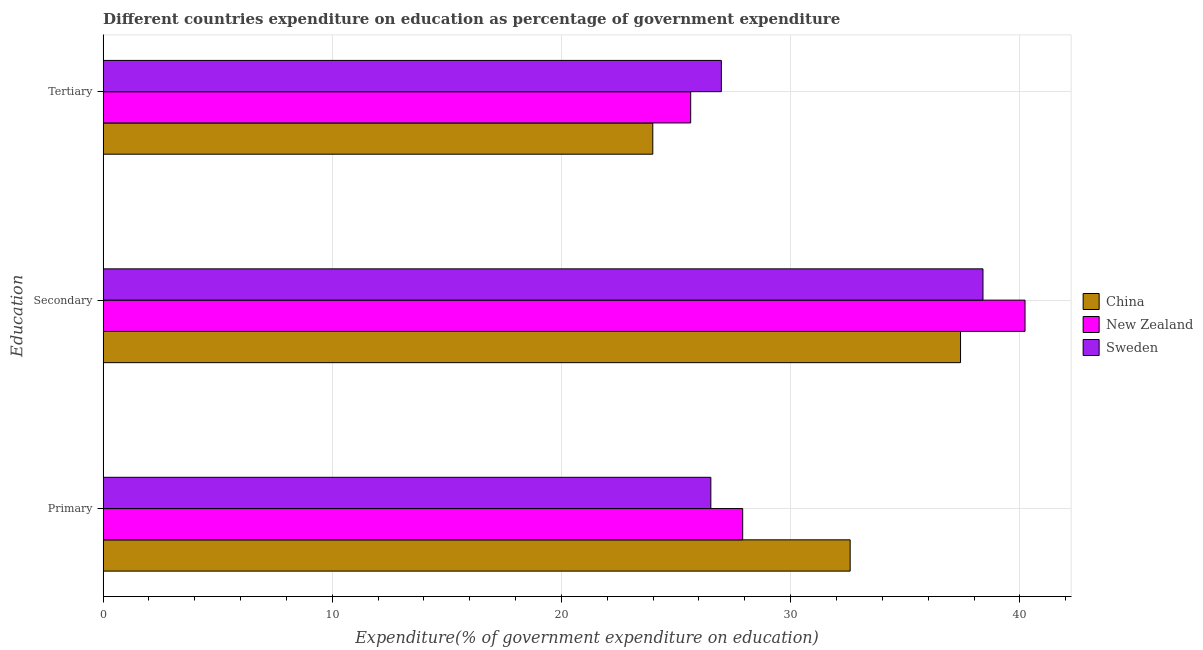How many different coloured bars are there?
Keep it short and to the point. 3. Are the number of bars on each tick of the Y-axis equal?
Provide a succinct answer. Yes. What is the label of the 2nd group of bars from the top?
Offer a very short reply. Secondary. What is the expenditure on tertiary education in China?
Keep it short and to the point. 23.98. Across all countries, what is the maximum expenditure on primary education?
Ensure brevity in your answer.  32.6. Across all countries, what is the minimum expenditure on tertiary education?
Your answer should be compact. 23.98. What is the total expenditure on primary education in the graph?
Give a very brief answer. 87.02. What is the difference between the expenditure on tertiary education in China and that in New Zealand?
Your answer should be compact. -1.65. What is the difference between the expenditure on primary education in New Zealand and the expenditure on tertiary education in Sweden?
Your answer should be compact. 0.93. What is the average expenditure on secondary education per country?
Offer a terse response. 38.68. What is the difference between the expenditure on secondary education and expenditure on tertiary education in Sweden?
Keep it short and to the point. 11.42. In how many countries, is the expenditure on secondary education greater than 6 %?
Offer a terse response. 3. What is the ratio of the expenditure on tertiary education in China to that in New Zealand?
Your response must be concise. 0.94. Is the expenditure on tertiary education in China less than that in New Zealand?
Give a very brief answer. Yes. What is the difference between the highest and the second highest expenditure on secondary education?
Your answer should be compact. 1.84. What is the difference between the highest and the lowest expenditure on secondary education?
Ensure brevity in your answer.  2.81. In how many countries, is the expenditure on tertiary education greater than the average expenditure on tertiary education taken over all countries?
Your response must be concise. 2. Is the sum of the expenditure on primary education in New Zealand and Sweden greater than the maximum expenditure on secondary education across all countries?
Your answer should be compact. Yes. What does the 3rd bar from the top in Secondary represents?
Offer a terse response. China. What does the 2nd bar from the bottom in Secondary represents?
Provide a short and direct response. New Zealand. Is it the case that in every country, the sum of the expenditure on primary education and expenditure on secondary education is greater than the expenditure on tertiary education?
Your answer should be compact. Yes. How many bars are there?
Your answer should be compact. 9. What is the difference between two consecutive major ticks on the X-axis?
Make the answer very short. 10. Are the values on the major ticks of X-axis written in scientific E-notation?
Provide a succinct answer. No. Does the graph contain any zero values?
Make the answer very short. No. Does the graph contain grids?
Your response must be concise. Yes. Where does the legend appear in the graph?
Keep it short and to the point. Center right. What is the title of the graph?
Ensure brevity in your answer.  Different countries expenditure on education as percentage of government expenditure. What is the label or title of the X-axis?
Offer a terse response. Expenditure(% of government expenditure on education). What is the label or title of the Y-axis?
Make the answer very short. Education. What is the Expenditure(% of government expenditure on education) of China in Primary?
Your response must be concise. 32.6. What is the Expenditure(% of government expenditure on education) in New Zealand in Primary?
Give a very brief answer. 27.91. What is the Expenditure(% of government expenditure on education) of Sweden in Primary?
Ensure brevity in your answer.  26.52. What is the Expenditure(% of government expenditure on education) in China in Secondary?
Give a very brief answer. 37.41. What is the Expenditure(% of government expenditure on education) in New Zealand in Secondary?
Provide a short and direct response. 40.23. What is the Expenditure(% of government expenditure on education) of Sweden in Secondary?
Your answer should be compact. 38.39. What is the Expenditure(% of government expenditure on education) of China in Tertiary?
Give a very brief answer. 23.98. What is the Expenditure(% of government expenditure on education) in New Zealand in Tertiary?
Your answer should be compact. 25.64. What is the Expenditure(% of government expenditure on education) in Sweden in Tertiary?
Make the answer very short. 26.98. Across all Education, what is the maximum Expenditure(% of government expenditure on education) of China?
Provide a succinct answer. 37.41. Across all Education, what is the maximum Expenditure(% of government expenditure on education) in New Zealand?
Your answer should be compact. 40.23. Across all Education, what is the maximum Expenditure(% of government expenditure on education) in Sweden?
Provide a succinct answer. 38.39. Across all Education, what is the minimum Expenditure(% of government expenditure on education) of China?
Keep it short and to the point. 23.98. Across all Education, what is the minimum Expenditure(% of government expenditure on education) of New Zealand?
Provide a succinct answer. 25.64. Across all Education, what is the minimum Expenditure(% of government expenditure on education) of Sweden?
Provide a succinct answer. 26.52. What is the total Expenditure(% of government expenditure on education) of China in the graph?
Provide a short and direct response. 93.99. What is the total Expenditure(% of government expenditure on education) in New Zealand in the graph?
Make the answer very short. 93.77. What is the total Expenditure(% of government expenditure on education) of Sweden in the graph?
Your answer should be compact. 91.89. What is the difference between the Expenditure(% of government expenditure on education) in China in Primary and that in Secondary?
Your answer should be compact. -4.82. What is the difference between the Expenditure(% of government expenditure on education) in New Zealand in Primary and that in Secondary?
Your answer should be compact. -12.32. What is the difference between the Expenditure(% of government expenditure on education) of Sweden in Primary and that in Secondary?
Ensure brevity in your answer.  -11.87. What is the difference between the Expenditure(% of government expenditure on education) in China in Primary and that in Tertiary?
Offer a terse response. 8.61. What is the difference between the Expenditure(% of government expenditure on education) of New Zealand in Primary and that in Tertiary?
Your response must be concise. 2.27. What is the difference between the Expenditure(% of government expenditure on education) in Sweden in Primary and that in Tertiary?
Ensure brevity in your answer.  -0.46. What is the difference between the Expenditure(% of government expenditure on education) of China in Secondary and that in Tertiary?
Offer a terse response. 13.43. What is the difference between the Expenditure(% of government expenditure on education) of New Zealand in Secondary and that in Tertiary?
Your answer should be very brief. 14.59. What is the difference between the Expenditure(% of government expenditure on education) of Sweden in Secondary and that in Tertiary?
Give a very brief answer. 11.42. What is the difference between the Expenditure(% of government expenditure on education) in China in Primary and the Expenditure(% of government expenditure on education) in New Zealand in Secondary?
Your answer should be very brief. -7.63. What is the difference between the Expenditure(% of government expenditure on education) of China in Primary and the Expenditure(% of government expenditure on education) of Sweden in Secondary?
Your answer should be very brief. -5.8. What is the difference between the Expenditure(% of government expenditure on education) in New Zealand in Primary and the Expenditure(% of government expenditure on education) in Sweden in Secondary?
Your response must be concise. -10.49. What is the difference between the Expenditure(% of government expenditure on education) in China in Primary and the Expenditure(% of government expenditure on education) in New Zealand in Tertiary?
Your answer should be compact. 6.96. What is the difference between the Expenditure(% of government expenditure on education) in China in Primary and the Expenditure(% of government expenditure on education) in Sweden in Tertiary?
Your answer should be very brief. 5.62. What is the difference between the Expenditure(% of government expenditure on education) in New Zealand in Primary and the Expenditure(% of government expenditure on education) in Sweden in Tertiary?
Keep it short and to the point. 0.93. What is the difference between the Expenditure(% of government expenditure on education) in China in Secondary and the Expenditure(% of government expenditure on education) in New Zealand in Tertiary?
Give a very brief answer. 11.77. What is the difference between the Expenditure(% of government expenditure on education) of China in Secondary and the Expenditure(% of government expenditure on education) of Sweden in Tertiary?
Provide a short and direct response. 10.44. What is the difference between the Expenditure(% of government expenditure on education) in New Zealand in Secondary and the Expenditure(% of government expenditure on education) in Sweden in Tertiary?
Ensure brevity in your answer.  13.25. What is the average Expenditure(% of government expenditure on education) in China per Education?
Your answer should be compact. 31.33. What is the average Expenditure(% of government expenditure on education) of New Zealand per Education?
Give a very brief answer. 31.26. What is the average Expenditure(% of government expenditure on education) of Sweden per Education?
Offer a terse response. 30.63. What is the difference between the Expenditure(% of government expenditure on education) in China and Expenditure(% of government expenditure on education) in New Zealand in Primary?
Keep it short and to the point. 4.69. What is the difference between the Expenditure(% of government expenditure on education) in China and Expenditure(% of government expenditure on education) in Sweden in Primary?
Make the answer very short. 6.08. What is the difference between the Expenditure(% of government expenditure on education) of New Zealand and Expenditure(% of government expenditure on education) of Sweden in Primary?
Offer a terse response. 1.39. What is the difference between the Expenditure(% of government expenditure on education) of China and Expenditure(% of government expenditure on education) of New Zealand in Secondary?
Your answer should be compact. -2.81. What is the difference between the Expenditure(% of government expenditure on education) of China and Expenditure(% of government expenditure on education) of Sweden in Secondary?
Keep it short and to the point. -0.98. What is the difference between the Expenditure(% of government expenditure on education) of New Zealand and Expenditure(% of government expenditure on education) of Sweden in Secondary?
Keep it short and to the point. 1.84. What is the difference between the Expenditure(% of government expenditure on education) of China and Expenditure(% of government expenditure on education) of New Zealand in Tertiary?
Offer a terse response. -1.65. What is the difference between the Expenditure(% of government expenditure on education) of China and Expenditure(% of government expenditure on education) of Sweden in Tertiary?
Offer a terse response. -2.99. What is the difference between the Expenditure(% of government expenditure on education) in New Zealand and Expenditure(% of government expenditure on education) in Sweden in Tertiary?
Ensure brevity in your answer.  -1.34. What is the ratio of the Expenditure(% of government expenditure on education) in China in Primary to that in Secondary?
Offer a terse response. 0.87. What is the ratio of the Expenditure(% of government expenditure on education) in New Zealand in Primary to that in Secondary?
Give a very brief answer. 0.69. What is the ratio of the Expenditure(% of government expenditure on education) of Sweden in Primary to that in Secondary?
Make the answer very short. 0.69. What is the ratio of the Expenditure(% of government expenditure on education) of China in Primary to that in Tertiary?
Your answer should be compact. 1.36. What is the ratio of the Expenditure(% of government expenditure on education) in New Zealand in Primary to that in Tertiary?
Give a very brief answer. 1.09. What is the ratio of the Expenditure(% of government expenditure on education) in China in Secondary to that in Tertiary?
Make the answer very short. 1.56. What is the ratio of the Expenditure(% of government expenditure on education) of New Zealand in Secondary to that in Tertiary?
Keep it short and to the point. 1.57. What is the ratio of the Expenditure(% of government expenditure on education) in Sweden in Secondary to that in Tertiary?
Make the answer very short. 1.42. What is the difference between the highest and the second highest Expenditure(% of government expenditure on education) of China?
Your answer should be compact. 4.82. What is the difference between the highest and the second highest Expenditure(% of government expenditure on education) of New Zealand?
Make the answer very short. 12.32. What is the difference between the highest and the second highest Expenditure(% of government expenditure on education) in Sweden?
Your answer should be very brief. 11.42. What is the difference between the highest and the lowest Expenditure(% of government expenditure on education) of China?
Keep it short and to the point. 13.43. What is the difference between the highest and the lowest Expenditure(% of government expenditure on education) in New Zealand?
Offer a very short reply. 14.59. What is the difference between the highest and the lowest Expenditure(% of government expenditure on education) in Sweden?
Your answer should be very brief. 11.87. 